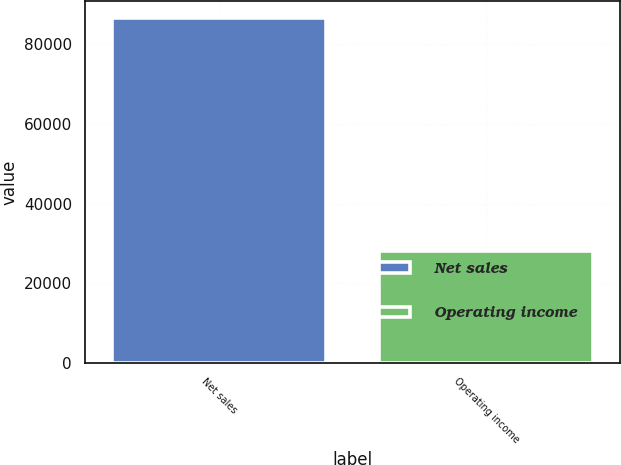Convert chart to OTSL. <chart><loc_0><loc_0><loc_500><loc_500><bar_chart><fcel>Net sales<fcel>Operating income<nl><fcel>86613<fcel>28172<nl></chart> 